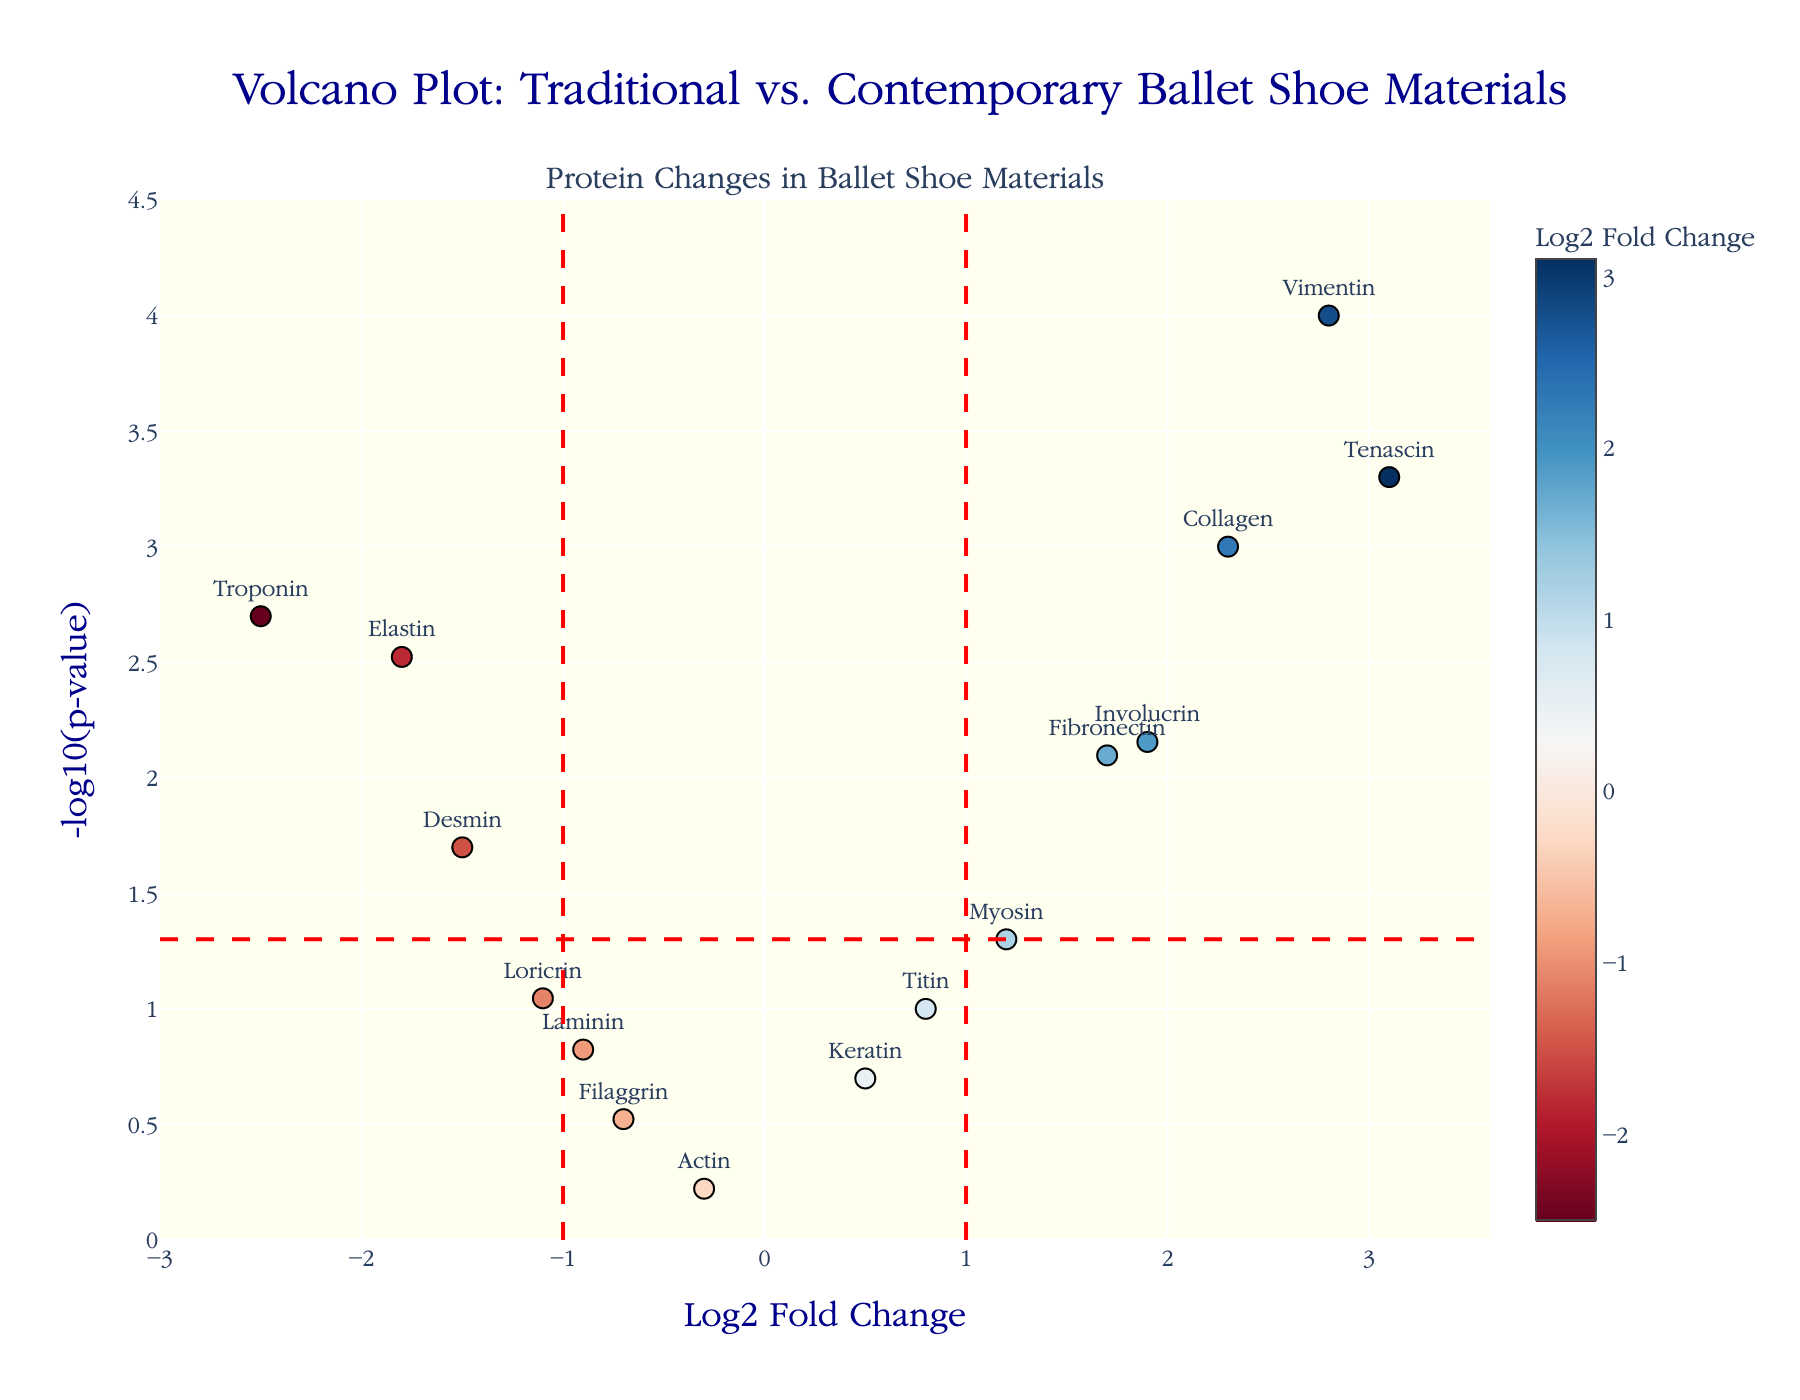What is the title of the plot? The title is displayed at the top of the figure.
Answer: Volcano Plot: Traditional vs. Contemporary Ballet Shoe Materials How many proteins have a p-value below 0.05? Count the data points that are above the horizontal red dashed line at -log10(0.05).
Answer: 9 Which protein has the highest log2 fold change? Look for the data point furthest to the right on the x-axis.
Answer: Tenascin What is the log2 fold change for Collagen? Locate the 'Collagen' label on the plot, then read its x-coordinate value.
Answer: 2.3 Which protein has the lowest p-value? Find the data point that is the highest on the y-axis.
Answer: Vimentin How does Troponin's fold change compare to Elastin's? Compare the x-coordinate values of the points labeled 'Troponin' and 'Elastin'. Troponin's log2 fold change is -2.5, while Elastin's is -1.8, indicating Troponin has a lower fold change.
Answer: Troponin < Elastin What is the y-axis value corresponding to a p-value of 0.05? -log10(0.05) can be computed as approximately 1.30. This matches the horizontal red dashed line's position on the y-axis.
Answer: 1.30 Which proteins have a log2 fold change between -1 and 1? Identify data points that lie between the vertical dashed lines at -1 and 1 on the x-axis. These proteins are Keratin, Laminin, Actin, and Titin.
Answer: Keratin, Laminin, Actin, Titin What is the relationship between p-value and -log10(p-value) in the plot? They are inversely related; as p-value decreases, -log10(p-value) increases, causing the data points to move higher on the y-axis.
Answer: Inverse Which protein is the furthest below the horizontal threshold line? Identify the data point with the highest -log10(p-value) below the horizontal line, which is the point with the highest vertical distance.
Answer: Desmin 